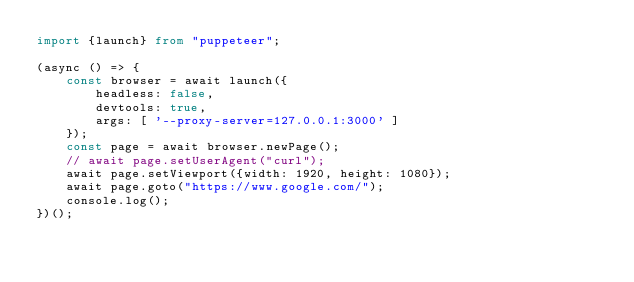Convert code to text. <code><loc_0><loc_0><loc_500><loc_500><_TypeScript_>import {launch} from "puppeteer";

(async () => {
    const browser = await launch({
        headless: false,
        devtools: true,
        args: [ '--proxy-server=127.0.0.1:3000' ]
    });
    const page = await browser.newPage();
    // await page.setUserAgent("curl");
    await page.setViewport({width: 1920, height: 1080});
    await page.goto("https://www.google.com/");
    console.log();
})();
</code> 